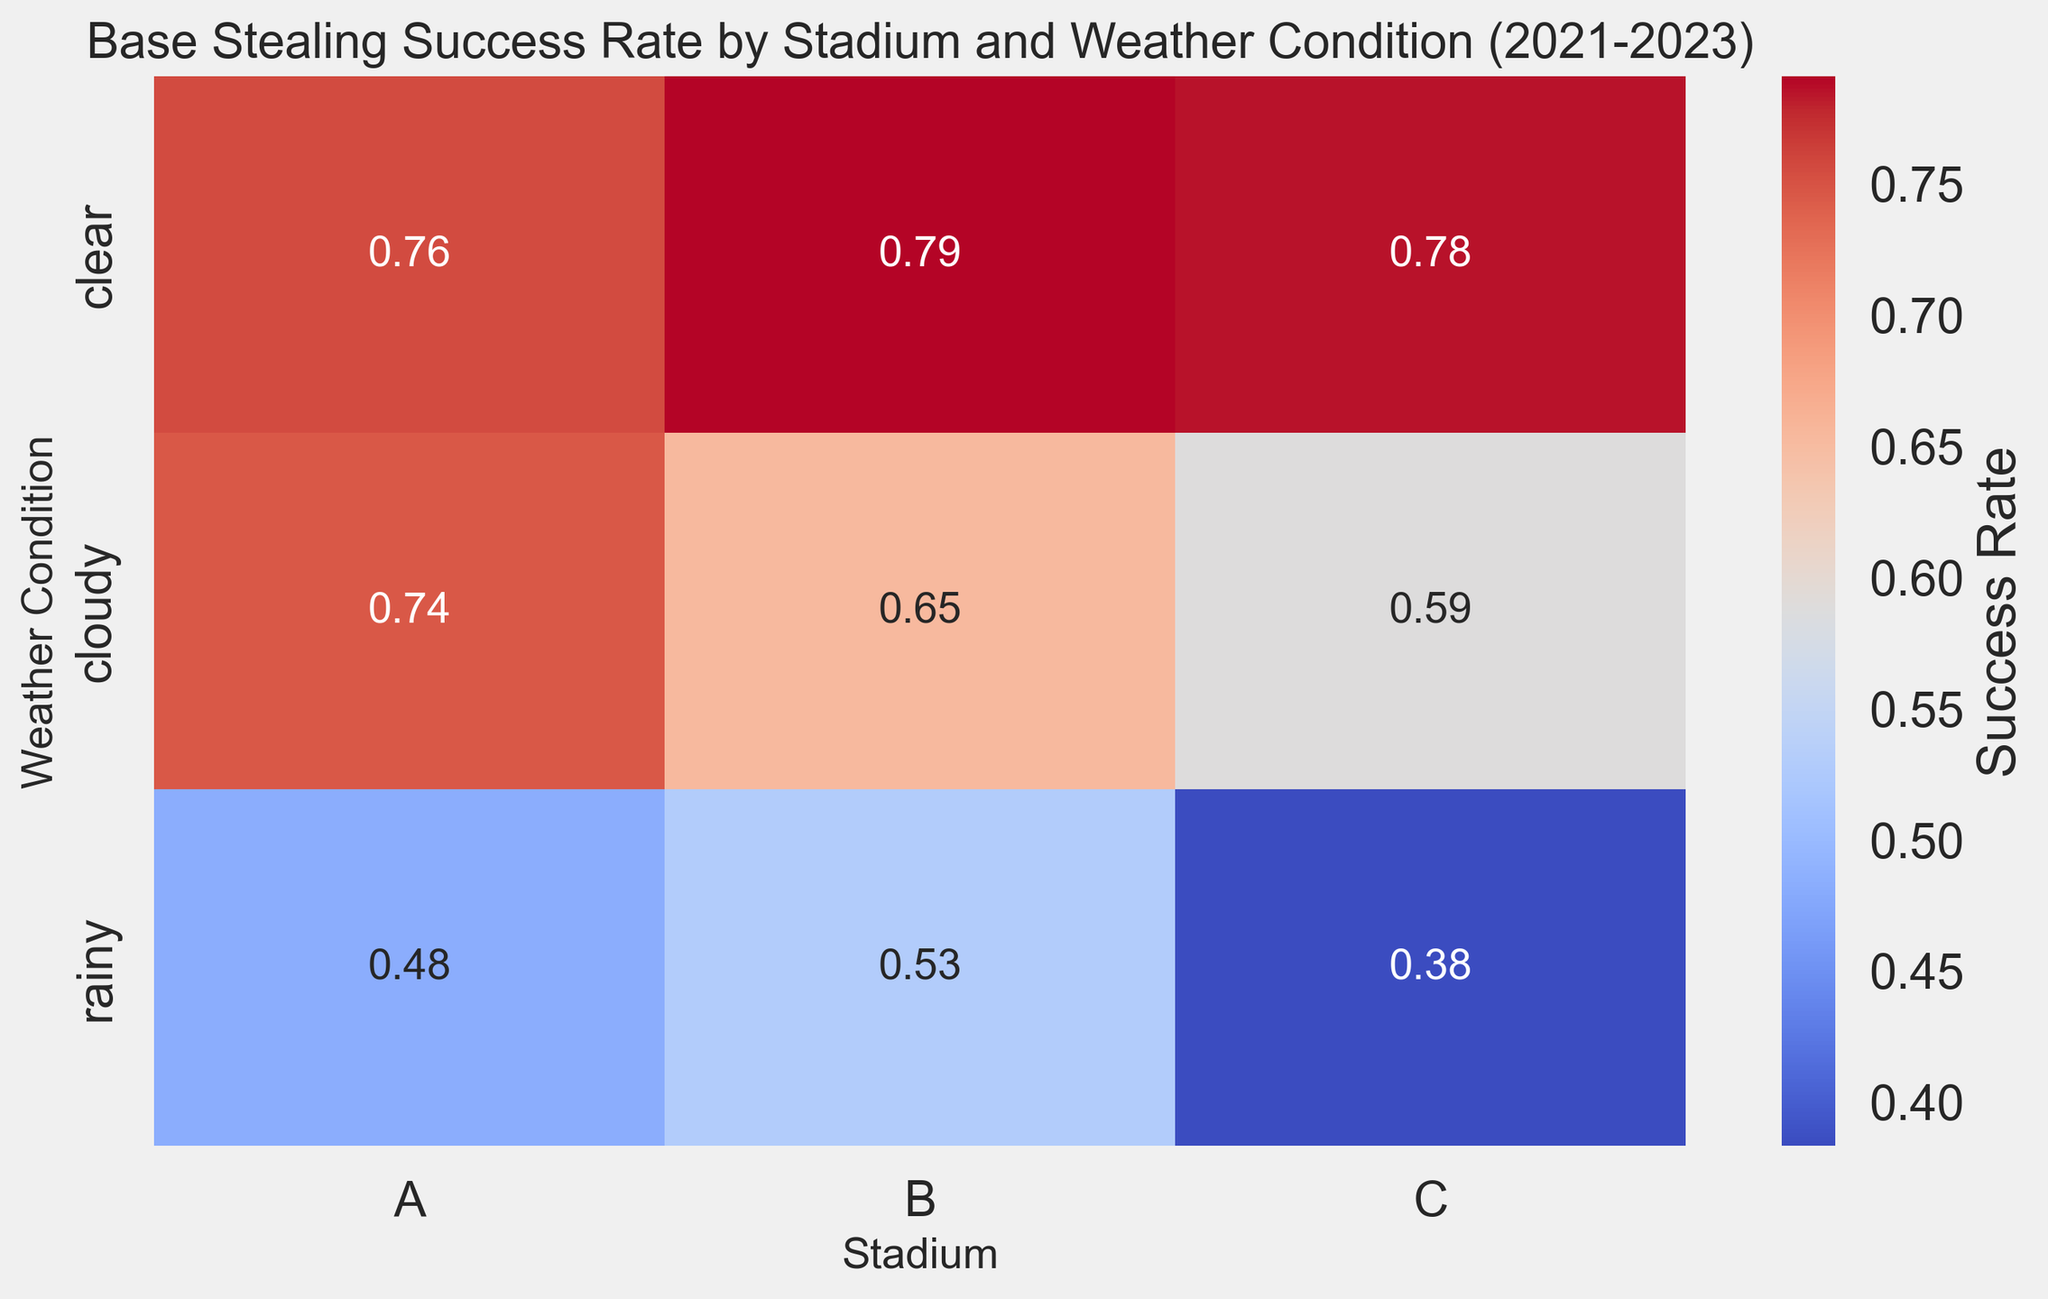what weather condition at Stadium A in 2022 had the highest base-stealing success rate? Look at the values for Stadium A in 2022 under all weather conditions and identify the highest success rate by its color intensity and annotation. Clear weather has a success rate of 38/50 = 0.76, cloudy is 22/30 = 0.73, and rainy is 10/20 = 0.50. Therefore, clear weather has the highest success rate.
Answer: clear Compare the success rate of base stealing at Stadium B under clear weather conditions between 2021 and 2023. Which year had the highest success rate? Visual comparison is made by looking at the annotated success rates for clear weather at Stadium B from 2021 to 2023. The success rates are: 2021 - 42/55 ≈ 0.76, 2022 - 48/60 ≈ 0.80, and 2023 - 55/68 ≈ 0.81. Therefore, the highest success rate was in 2023.
Answer: 2023 Calculate the average base-stealing success rate for Stadium C during rainy weather conditions from 2021 to 2023. For Stadium C, identify the success rates under rainy conditions for each year: 2021 - 3/9 ≈ 0.33, 2022 - 4/10 = 0.40, 2023 - 5/12 ≈ 0.42. Sum these values and divide by the number of years to get the average: (0.33 + 0.40 + 0.42) / 3 ≈ 0.38.
Answer: 0.38 Which stadium had the most consistent base-stealing success rate across all weather conditions? Visually inspect the heatmap and determine which stadium has similar shades of color (indicating consistent success rates) for all weather conditions. Stadium A shows the least variation in color intensity, suggesting consistent success rates.
Answer: Stadium A Was base stealing generally more successful under clear or rainy weather conditions across all stadiums? Compare the overall color intensity and annotated success rates for clear vs. rainy weather conditions across all stadiums. Clear weather conditions consistently show higher success rates (ranging from around 0.75 to 0.81) compared to rainy conditions (ranging from around 0.33 to 0.50).
Answer: clear Which stadium and weather combination had the lowest base-stealing success rate across all seasons? Identify the cell with the lowest success rate in the heatmap by checking the smallest annotated value. The combination is Stadium C and rainy weather in 2021 with a success rate of 3/9 ≈ 0.33.
Answer: Stadium C and rainy How did the success rates at Stadium A change between 2021 and 2023 under cloudy weather conditions? Identify the success rates for Stadium A under cloudy weather in 2021 (18/25 = 0.72), 2022 (22/30 ≈ 0.73), and 2023 (25/32 ≈ 0.78). The success rate shows a gradual increase over the three years.
Answer: increased What weather condition at Stadium C showed the most significant improvement in success rate between 2021 and 2023? Compare the success rates for each weather condition at Stadium C between 2021 and 2023. The biggest improvement in percentage points is seen in clear weather, from 50/65 ≈ 0.77 in 2021 to 60/75 = 0.80 in 2023, showing a slight increase.
Answer: clear Which weather condition had the lowest variability in base-stealing success rates across all stadiums? Determine the variability by comparing the range of success rates for each weather condition across all stadiums. Clear weather success rates range narrowly between about 0.75 to 0.81, indicating the lowest variability compared to cloudy and rainy conditions.
Answer: clear 